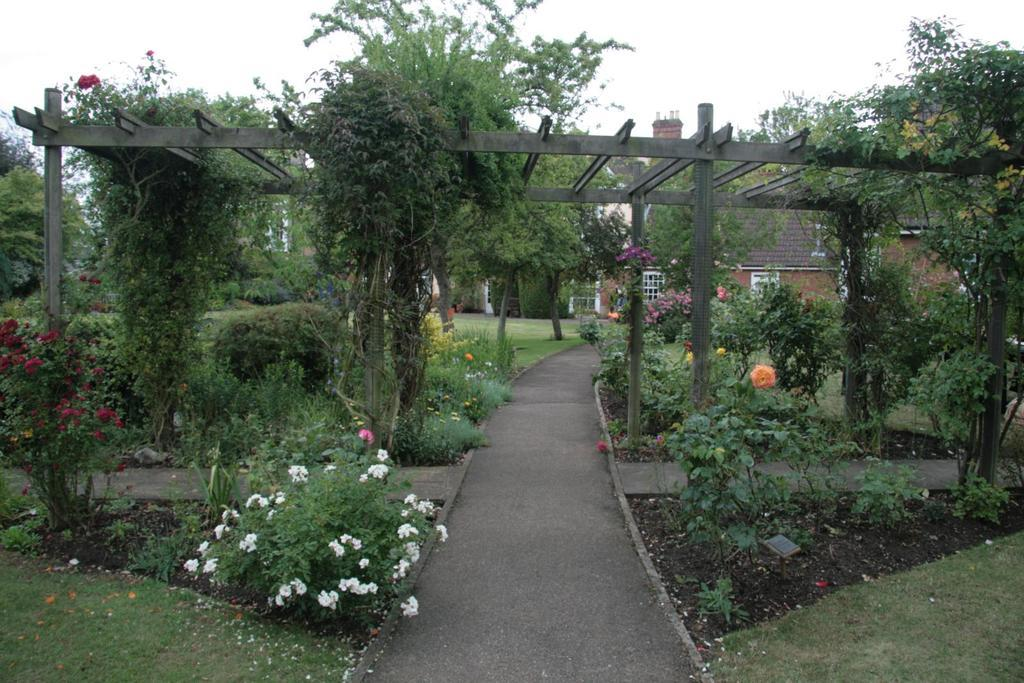What type of vegetation is present on the ground in the image? There are plants and grass on the ground in the image. What colors are the flowers on the left side of the image? The flowers on the left side of the image are red and white. What can be seen in the background of the image? There is a house and the sky visible in the background of the image. How many teeth can be seen in the image? There are no teeth visible in the image. What type of cattle is present in the image? There is no cattle present in the image. 